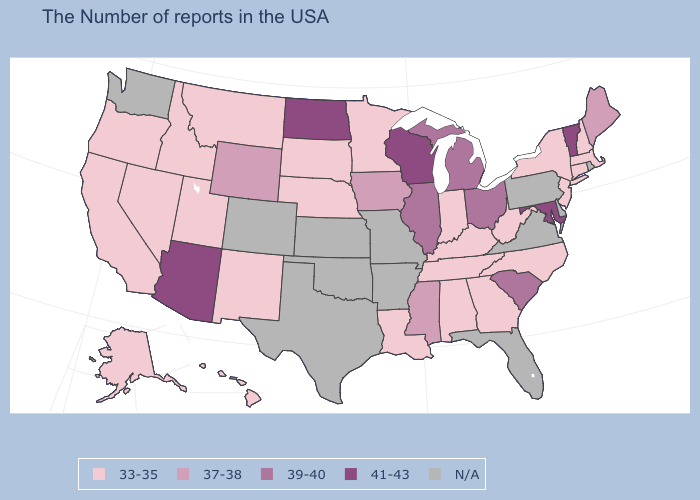Name the states that have a value in the range 41-43?
Give a very brief answer. Vermont, Maryland, Wisconsin, North Dakota, Arizona. What is the value of Missouri?
Write a very short answer. N/A. What is the highest value in the USA?
Short answer required. 41-43. Name the states that have a value in the range N/A?
Write a very short answer. Rhode Island, Delaware, Pennsylvania, Virginia, Florida, Missouri, Arkansas, Kansas, Oklahoma, Texas, Colorado, Washington. Which states have the lowest value in the Northeast?
Short answer required. Massachusetts, New Hampshire, Connecticut, New York, New Jersey. What is the highest value in the USA?
Write a very short answer. 41-43. Which states have the lowest value in the West?
Keep it brief. New Mexico, Utah, Montana, Idaho, Nevada, California, Oregon, Alaska, Hawaii. How many symbols are there in the legend?
Quick response, please. 5. What is the value of Indiana?
Write a very short answer. 33-35. How many symbols are there in the legend?
Give a very brief answer. 5. Is the legend a continuous bar?
Keep it brief. No. Among the states that border New Hampshire , which have the lowest value?
Concise answer only. Massachusetts. What is the value of Idaho?
Concise answer only. 33-35. 